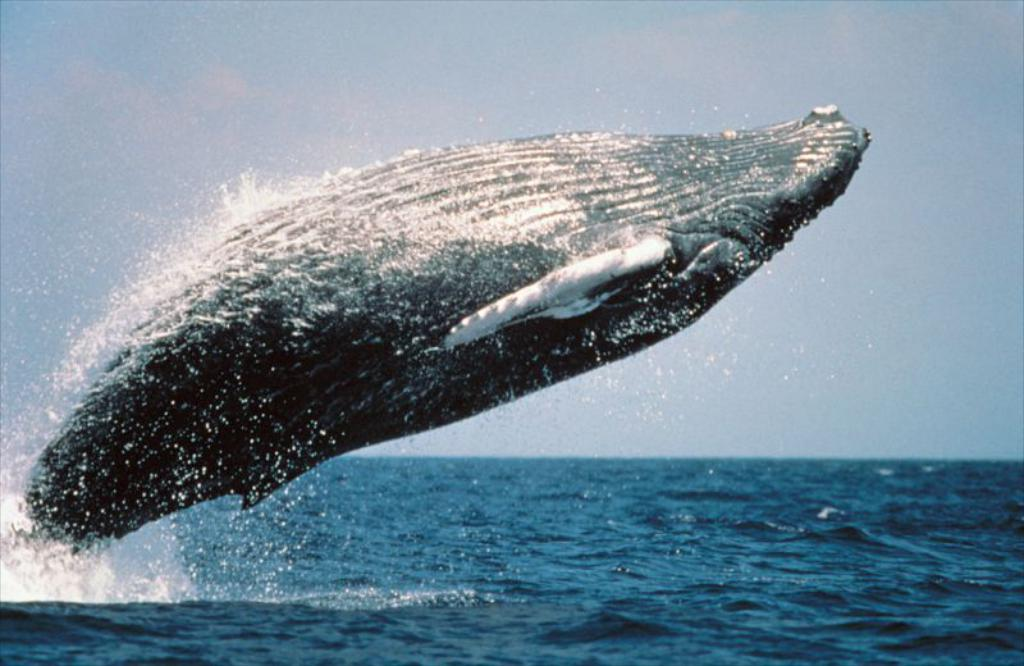Where was the image taken? The image was taken outdoors. What can be seen at the bottom of the image? There is a sea at the bottom of the image. What is visible at the top of the image? There is a sky with clouds at the top of the image. What is the main subject in the middle of the image? There is a whale in the middle of the image. What type of brick is being used to build the hospital in the image? There is no hospital or brick present in the image; it features a whale in the sea. 